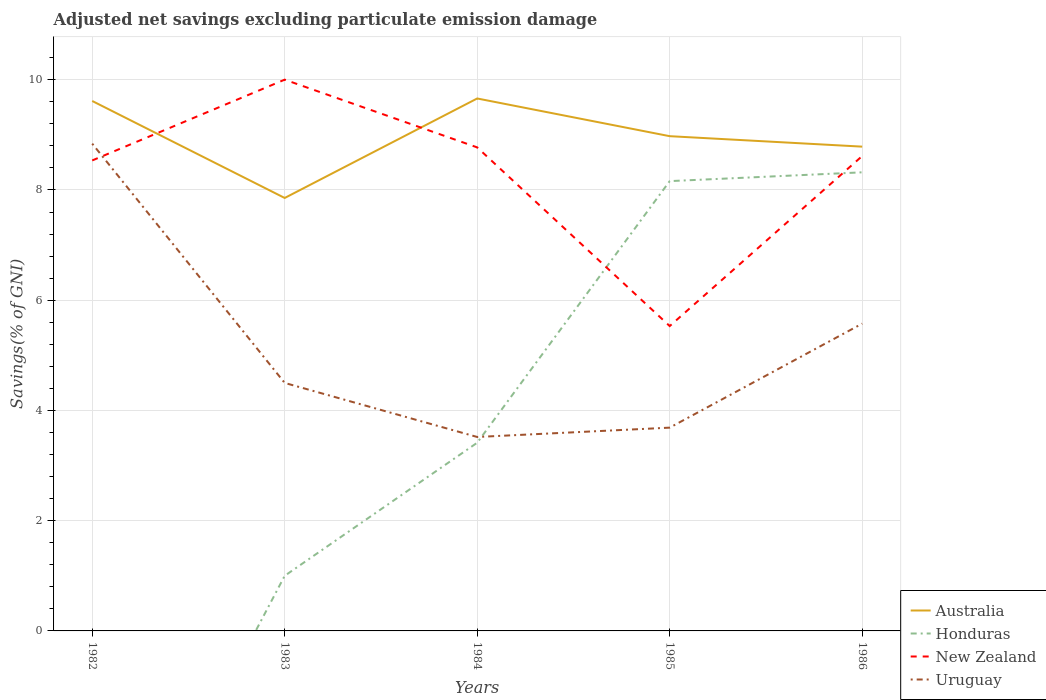How many different coloured lines are there?
Your response must be concise. 4. Does the line corresponding to Australia intersect with the line corresponding to Honduras?
Keep it short and to the point. No. Across all years, what is the maximum adjusted net savings in New Zealand?
Offer a very short reply. 5.53. What is the total adjusted net savings in Australia in the graph?
Your answer should be compact. 0.83. What is the difference between the highest and the second highest adjusted net savings in Uruguay?
Your response must be concise. 5.32. Is the adjusted net savings in Uruguay strictly greater than the adjusted net savings in Australia over the years?
Your answer should be compact. Yes. How many lines are there?
Your answer should be compact. 4. Are the values on the major ticks of Y-axis written in scientific E-notation?
Provide a short and direct response. No. Does the graph contain any zero values?
Ensure brevity in your answer.  Yes. Where does the legend appear in the graph?
Ensure brevity in your answer.  Bottom right. How many legend labels are there?
Ensure brevity in your answer.  4. What is the title of the graph?
Your response must be concise. Adjusted net savings excluding particulate emission damage. Does "Dominican Republic" appear as one of the legend labels in the graph?
Offer a terse response. No. What is the label or title of the Y-axis?
Your answer should be very brief. Savings(% of GNI). What is the Savings(% of GNI) in Australia in 1982?
Make the answer very short. 9.61. What is the Savings(% of GNI) of New Zealand in 1982?
Make the answer very short. 8.54. What is the Savings(% of GNI) in Uruguay in 1982?
Give a very brief answer. 8.84. What is the Savings(% of GNI) of Australia in 1983?
Offer a terse response. 7.85. What is the Savings(% of GNI) in Honduras in 1983?
Give a very brief answer. 1. What is the Savings(% of GNI) in New Zealand in 1983?
Offer a very short reply. 10. What is the Savings(% of GNI) in Uruguay in 1983?
Keep it short and to the point. 4.5. What is the Savings(% of GNI) of Australia in 1984?
Offer a terse response. 9.66. What is the Savings(% of GNI) in Honduras in 1984?
Offer a terse response. 3.41. What is the Savings(% of GNI) in New Zealand in 1984?
Ensure brevity in your answer.  8.77. What is the Savings(% of GNI) of Uruguay in 1984?
Ensure brevity in your answer.  3.52. What is the Savings(% of GNI) of Australia in 1985?
Your answer should be compact. 8.98. What is the Savings(% of GNI) in Honduras in 1985?
Offer a very short reply. 8.16. What is the Savings(% of GNI) in New Zealand in 1985?
Keep it short and to the point. 5.53. What is the Savings(% of GNI) of Uruguay in 1985?
Your answer should be compact. 3.69. What is the Savings(% of GNI) of Australia in 1986?
Provide a succinct answer. 8.79. What is the Savings(% of GNI) of Honduras in 1986?
Provide a succinct answer. 8.32. What is the Savings(% of GNI) of New Zealand in 1986?
Give a very brief answer. 8.62. What is the Savings(% of GNI) in Uruguay in 1986?
Offer a very short reply. 5.58. Across all years, what is the maximum Savings(% of GNI) of Australia?
Give a very brief answer. 9.66. Across all years, what is the maximum Savings(% of GNI) of Honduras?
Keep it short and to the point. 8.32. Across all years, what is the maximum Savings(% of GNI) in New Zealand?
Make the answer very short. 10. Across all years, what is the maximum Savings(% of GNI) of Uruguay?
Keep it short and to the point. 8.84. Across all years, what is the minimum Savings(% of GNI) of Australia?
Your answer should be very brief. 7.85. Across all years, what is the minimum Savings(% of GNI) in Honduras?
Give a very brief answer. 0. Across all years, what is the minimum Savings(% of GNI) in New Zealand?
Offer a very short reply. 5.53. Across all years, what is the minimum Savings(% of GNI) in Uruguay?
Ensure brevity in your answer.  3.52. What is the total Savings(% of GNI) of Australia in the graph?
Offer a terse response. 44.89. What is the total Savings(% of GNI) in Honduras in the graph?
Make the answer very short. 20.9. What is the total Savings(% of GNI) in New Zealand in the graph?
Provide a short and direct response. 41.46. What is the total Savings(% of GNI) of Uruguay in the graph?
Your response must be concise. 26.12. What is the difference between the Savings(% of GNI) of Australia in 1982 and that in 1983?
Offer a terse response. 1.76. What is the difference between the Savings(% of GNI) in New Zealand in 1982 and that in 1983?
Your answer should be very brief. -1.47. What is the difference between the Savings(% of GNI) of Uruguay in 1982 and that in 1983?
Provide a short and direct response. 4.34. What is the difference between the Savings(% of GNI) of Australia in 1982 and that in 1984?
Your answer should be compact. -0.05. What is the difference between the Savings(% of GNI) of New Zealand in 1982 and that in 1984?
Offer a very short reply. -0.24. What is the difference between the Savings(% of GNI) of Uruguay in 1982 and that in 1984?
Make the answer very short. 5.32. What is the difference between the Savings(% of GNI) of Australia in 1982 and that in 1985?
Keep it short and to the point. 0.64. What is the difference between the Savings(% of GNI) of New Zealand in 1982 and that in 1985?
Keep it short and to the point. 3. What is the difference between the Savings(% of GNI) of Uruguay in 1982 and that in 1985?
Provide a succinct answer. 5.15. What is the difference between the Savings(% of GNI) of Australia in 1982 and that in 1986?
Your answer should be compact. 0.83. What is the difference between the Savings(% of GNI) in New Zealand in 1982 and that in 1986?
Provide a succinct answer. -0.08. What is the difference between the Savings(% of GNI) in Uruguay in 1982 and that in 1986?
Give a very brief answer. 3.27. What is the difference between the Savings(% of GNI) in Australia in 1983 and that in 1984?
Give a very brief answer. -1.81. What is the difference between the Savings(% of GNI) in Honduras in 1983 and that in 1984?
Provide a succinct answer. -2.41. What is the difference between the Savings(% of GNI) in New Zealand in 1983 and that in 1984?
Ensure brevity in your answer.  1.23. What is the difference between the Savings(% of GNI) in Uruguay in 1983 and that in 1984?
Offer a very short reply. 0.98. What is the difference between the Savings(% of GNI) of Australia in 1983 and that in 1985?
Your answer should be very brief. -1.12. What is the difference between the Savings(% of GNI) of Honduras in 1983 and that in 1985?
Offer a terse response. -7.16. What is the difference between the Savings(% of GNI) of New Zealand in 1983 and that in 1985?
Offer a very short reply. 4.47. What is the difference between the Savings(% of GNI) of Uruguay in 1983 and that in 1985?
Your answer should be compact. 0.81. What is the difference between the Savings(% of GNI) in Australia in 1983 and that in 1986?
Make the answer very short. -0.93. What is the difference between the Savings(% of GNI) of Honduras in 1983 and that in 1986?
Provide a succinct answer. -7.32. What is the difference between the Savings(% of GNI) in New Zealand in 1983 and that in 1986?
Give a very brief answer. 1.39. What is the difference between the Savings(% of GNI) in Uruguay in 1983 and that in 1986?
Your answer should be compact. -1.08. What is the difference between the Savings(% of GNI) in Australia in 1984 and that in 1985?
Offer a terse response. 0.68. What is the difference between the Savings(% of GNI) of Honduras in 1984 and that in 1985?
Provide a short and direct response. -4.75. What is the difference between the Savings(% of GNI) in New Zealand in 1984 and that in 1985?
Offer a very short reply. 3.24. What is the difference between the Savings(% of GNI) in Uruguay in 1984 and that in 1985?
Your response must be concise. -0.17. What is the difference between the Savings(% of GNI) of Australia in 1984 and that in 1986?
Your answer should be very brief. 0.87. What is the difference between the Savings(% of GNI) in Honduras in 1984 and that in 1986?
Ensure brevity in your answer.  -4.91. What is the difference between the Savings(% of GNI) of New Zealand in 1984 and that in 1986?
Make the answer very short. 0.16. What is the difference between the Savings(% of GNI) in Uruguay in 1984 and that in 1986?
Provide a short and direct response. -2.06. What is the difference between the Savings(% of GNI) of Australia in 1985 and that in 1986?
Your response must be concise. 0.19. What is the difference between the Savings(% of GNI) of Honduras in 1985 and that in 1986?
Provide a succinct answer. -0.16. What is the difference between the Savings(% of GNI) in New Zealand in 1985 and that in 1986?
Your answer should be compact. -3.08. What is the difference between the Savings(% of GNI) of Uruguay in 1985 and that in 1986?
Provide a succinct answer. -1.89. What is the difference between the Savings(% of GNI) of Australia in 1982 and the Savings(% of GNI) of Honduras in 1983?
Provide a succinct answer. 8.61. What is the difference between the Savings(% of GNI) in Australia in 1982 and the Savings(% of GNI) in New Zealand in 1983?
Ensure brevity in your answer.  -0.39. What is the difference between the Savings(% of GNI) of Australia in 1982 and the Savings(% of GNI) of Uruguay in 1983?
Offer a terse response. 5.12. What is the difference between the Savings(% of GNI) of New Zealand in 1982 and the Savings(% of GNI) of Uruguay in 1983?
Give a very brief answer. 4.04. What is the difference between the Savings(% of GNI) in Australia in 1982 and the Savings(% of GNI) in Honduras in 1984?
Your answer should be compact. 6.2. What is the difference between the Savings(% of GNI) of Australia in 1982 and the Savings(% of GNI) of New Zealand in 1984?
Keep it short and to the point. 0.84. What is the difference between the Savings(% of GNI) of Australia in 1982 and the Savings(% of GNI) of Uruguay in 1984?
Keep it short and to the point. 6.1. What is the difference between the Savings(% of GNI) in New Zealand in 1982 and the Savings(% of GNI) in Uruguay in 1984?
Provide a short and direct response. 5.02. What is the difference between the Savings(% of GNI) in Australia in 1982 and the Savings(% of GNI) in Honduras in 1985?
Give a very brief answer. 1.45. What is the difference between the Savings(% of GNI) of Australia in 1982 and the Savings(% of GNI) of New Zealand in 1985?
Offer a terse response. 4.08. What is the difference between the Savings(% of GNI) of Australia in 1982 and the Savings(% of GNI) of Uruguay in 1985?
Offer a terse response. 5.93. What is the difference between the Savings(% of GNI) in New Zealand in 1982 and the Savings(% of GNI) in Uruguay in 1985?
Your answer should be compact. 4.85. What is the difference between the Savings(% of GNI) in Australia in 1982 and the Savings(% of GNI) in Honduras in 1986?
Your answer should be very brief. 1.29. What is the difference between the Savings(% of GNI) in Australia in 1982 and the Savings(% of GNI) in Uruguay in 1986?
Your answer should be very brief. 4.04. What is the difference between the Savings(% of GNI) in New Zealand in 1982 and the Savings(% of GNI) in Uruguay in 1986?
Offer a very short reply. 2.96. What is the difference between the Savings(% of GNI) in Australia in 1983 and the Savings(% of GNI) in Honduras in 1984?
Ensure brevity in your answer.  4.44. What is the difference between the Savings(% of GNI) in Australia in 1983 and the Savings(% of GNI) in New Zealand in 1984?
Give a very brief answer. -0.92. What is the difference between the Savings(% of GNI) in Australia in 1983 and the Savings(% of GNI) in Uruguay in 1984?
Provide a succinct answer. 4.34. What is the difference between the Savings(% of GNI) in Honduras in 1983 and the Savings(% of GNI) in New Zealand in 1984?
Offer a very short reply. -7.77. What is the difference between the Savings(% of GNI) of Honduras in 1983 and the Savings(% of GNI) of Uruguay in 1984?
Keep it short and to the point. -2.52. What is the difference between the Savings(% of GNI) of New Zealand in 1983 and the Savings(% of GNI) of Uruguay in 1984?
Give a very brief answer. 6.48. What is the difference between the Savings(% of GNI) of Australia in 1983 and the Savings(% of GNI) of Honduras in 1985?
Provide a short and direct response. -0.31. What is the difference between the Savings(% of GNI) of Australia in 1983 and the Savings(% of GNI) of New Zealand in 1985?
Your answer should be very brief. 2.32. What is the difference between the Savings(% of GNI) in Australia in 1983 and the Savings(% of GNI) in Uruguay in 1985?
Provide a succinct answer. 4.17. What is the difference between the Savings(% of GNI) in Honduras in 1983 and the Savings(% of GNI) in New Zealand in 1985?
Offer a very short reply. -4.53. What is the difference between the Savings(% of GNI) of Honduras in 1983 and the Savings(% of GNI) of Uruguay in 1985?
Give a very brief answer. -2.69. What is the difference between the Savings(% of GNI) of New Zealand in 1983 and the Savings(% of GNI) of Uruguay in 1985?
Your response must be concise. 6.31. What is the difference between the Savings(% of GNI) of Australia in 1983 and the Savings(% of GNI) of Honduras in 1986?
Give a very brief answer. -0.47. What is the difference between the Savings(% of GNI) in Australia in 1983 and the Savings(% of GNI) in New Zealand in 1986?
Your answer should be compact. -0.76. What is the difference between the Savings(% of GNI) in Australia in 1983 and the Savings(% of GNI) in Uruguay in 1986?
Make the answer very short. 2.28. What is the difference between the Savings(% of GNI) of Honduras in 1983 and the Savings(% of GNI) of New Zealand in 1986?
Make the answer very short. -7.62. What is the difference between the Savings(% of GNI) of Honduras in 1983 and the Savings(% of GNI) of Uruguay in 1986?
Keep it short and to the point. -4.58. What is the difference between the Savings(% of GNI) in New Zealand in 1983 and the Savings(% of GNI) in Uruguay in 1986?
Your answer should be compact. 4.43. What is the difference between the Savings(% of GNI) in Australia in 1984 and the Savings(% of GNI) in Honduras in 1985?
Your response must be concise. 1.5. What is the difference between the Savings(% of GNI) of Australia in 1984 and the Savings(% of GNI) of New Zealand in 1985?
Give a very brief answer. 4.13. What is the difference between the Savings(% of GNI) of Australia in 1984 and the Savings(% of GNI) of Uruguay in 1985?
Your response must be concise. 5.97. What is the difference between the Savings(% of GNI) in Honduras in 1984 and the Savings(% of GNI) in New Zealand in 1985?
Keep it short and to the point. -2.12. What is the difference between the Savings(% of GNI) of Honduras in 1984 and the Savings(% of GNI) of Uruguay in 1985?
Your answer should be compact. -0.27. What is the difference between the Savings(% of GNI) of New Zealand in 1984 and the Savings(% of GNI) of Uruguay in 1985?
Your response must be concise. 5.08. What is the difference between the Savings(% of GNI) of Australia in 1984 and the Savings(% of GNI) of Honduras in 1986?
Your answer should be compact. 1.34. What is the difference between the Savings(% of GNI) in Australia in 1984 and the Savings(% of GNI) in New Zealand in 1986?
Ensure brevity in your answer.  1.04. What is the difference between the Savings(% of GNI) in Australia in 1984 and the Savings(% of GNI) in Uruguay in 1986?
Your answer should be compact. 4.08. What is the difference between the Savings(% of GNI) in Honduras in 1984 and the Savings(% of GNI) in New Zealand in 1986?
Offer a terse response. -5.2. What is the difference between the Savings(% of GNI) of Honduras in 1984 and the Savings(% of GNI) of Uruguay in 1986?
Offer a terse response. -2.16. What is the difference between the Savings(% of GNI) of New Zealand in 1984 and the Savings(% of GNI) of Uruguay in 1986?
Your answer should be compact. 3.2. What is the difference between the Savings(% of GNI) of Australia in 1985 and the Savings(% of GNI) of Honduras in 1986?
Keep it short and to the point. 0.66. What is the difference between the Savings(% of GNI) in Australia in 1985 and the Savings(% of GNI) in New Zealand in 1986?
Make the answer very short. 0.36. What is the difference between the Savings(% of GNI) of Australia in 1985 and the Savings(% of GNI) of Uruguay in 1986?
Make the answer very short. 3.4. What is the difference between the Savings(% of GNI) in Honduras in 1985 and the Savings(% of GNI) in New Zealand in 1986?
Ensure brevity in your answer.  -0.46. What is the difference between the Savings(% of GNI) of Honduras in 1985 and the Savings(% of GNI) of Uruguay in 1986?
Ensure brevity in your answer.  2.59. What is the difference between the Savings(% of GNI) in New Zealand in 1985 and the Savings(% of GNI) in Uruguay in 1986?
Provide a succinct answer. -0.04. What is the average Savings(% of GNI) of Australia per year?
Provide a short and direct response. 8.98. What is the average Savings(% of GNI) of Honduras per year?
Make the answer very short. 4.18. What is the average Savings(% of GNI) in New Zealand per year?
Keep it short and to the point. 8.29. What is the average Savings(% of GNI) of Uruguay per year?
Make the answer very short. 5.22. In the year 1982, what is the difference between the Savings(% of GNI) of Australia and Savings(% of GNI) of New Zealand?
Keep it short and to the point. 1.08. In the year 1982, what is the difference between the Savings(% of GNI) of Australia and Savings(% of GNI) of Uruguay?
Provide a short and direct response. 0.77. In the year 1982, what is the difference between the Savings(% of GNI) of New Zealand and Savings(% of GNI) of Uruguay?
Your answer should be compact. -0.3. In the year 1983, what is the difference between the Savings(% of GNI) in Australia and Savings(% of GNI) in Honduras?
Provide a short and direct response. 6.85. In the year 1983, what is the difference between the Savings(% of GNI) of Australia and Savings(% of GNI) of New Zealand?
Ensure brevity in your answer.  -2.15. In the year 1983, what is the difference between the Savings(% of GNI) in Australia and Savings(% of GNI) in Uruguay?
Provide a short and direct response. 3.36. In the year 1983, what is the difference between the Savings(% of GNI) of Honduras and Savings(% of GNI) of New Zealand?
Give a very brief answer. -9. In the year 1983, what is the difference between the Savings(% of GNI) in Honduras and Savings(% of GNI) in Uruguay?
Make the answer very short. -3.5. In the year 1983, what is the difference between the Savings(% of GNI) of New Zealand and Savings(% of GNI) of Uruguay?
Provide a succinct answer. 5.5. In the year 1984, what is the difference between the Savings(% of GNI) of Australia and Savings(% of GNI) of Honduras?
Offer a very short reply. 6.25. In the year 1984, what is the difference between the Savings(% of GNI) in Australia and Savings(% of GNI) in New Zealand?
Your answer should be compact. 0.89. In the year 1984, what is the difference between the Savings(% of GNI) of Australia and Savings(% of GNI) of Uruguay?
Provide a short and direct response. 6.14. In the year 1984, what is the difference between the Savings(% of GNI) of Honduras and Savings(% of GNI) of New Zealand?
Your answer should be compact. -5.36. In the year 1984, what is the difference between the Savings(% of GNI) of Honduras and Savings(% of GNI) of Uruguay?
Your answer should be very brief. -0.1. In the year 1984, what is the difference between the Savings(% of GNI) of New Zealand and Savings(% of GNI) of Uruguay?
Keep it short and to the point. 5.25. In the year 1985, what is the difference between the Savings(% of GNI) of Australia and Savings(% of GNI) of Honduras?
Ensure brevity in your answer.  0.82. In the year 1985, what is the difference between the Savings(% of GNI) in Australia and Savings(% of GNI) in New Zealand?
Make the answer very short. 3.44. In the year 1985, what is the difference between the Savings(% of GNI) of Australia and Savings(% of GNI) of Uruguay?
Keep it short and to the point. 5.29. In the year 1985, what is the difference between the Savings(% of GNI) of Honduras and Savings(% of GNI) of New Zealand?
Offer a very short reply. 2.63. In the year 1985, what is the difference between the Savings(% of GNI) of Honduras and Savings(% of GNI) of Uruguay?
Offer a terse response. 4.47. In the year 1985, what is the difference between the Savings(% of GNI) of New Zealand and Savings(% of GNI) of Uruguay?
Provide a short and direct response. 1.84. In the year 1986, what is the difference between the Savings(% of GNI) of Australia and Savings(% of GNI) of Honduras?
Make the answer very short. 0.47. In the year 1986, what is the difference between the Savings(% of GNI) of Australia and Savings(% of GNI) of New Zealand?
Make the answer very short. 0.17. In the year 1986, what is the difference between the Savings(% of GNI) of Australia and Savings(% of GNI) of Uruguay?
Your response must be concise. 3.21. In the year 1986, what is the difference between the Savings(% of GNI) of Honduras and Savings(% of GNI) of New Zealand?
Offer a terse response. -0.3. In the year 1986, what is the difference between the Savings(% of GNI) in Honduras and Savings(% of GNI) in Uruguay?
Give a very brief answer. 2.75. In the year 1986, what is the difference between the Savings(% of GNI) of New Zealand and Savings(% of GNI) of Uruguay?
Your answer should be very brief. 3.04. What is the ratio of the Savings(% of GNI) of Australia in 1982 to that in 1983?
Offer a very short reply. 1.22. What is the ratio of the Savings(% of GNI) in New Zealand in 1982 to that in 1983?
Your response must be concise. 0.85. What is the ratio of the Savings(% of GNI) of Uruguay in 1982 to that in 1983?
Provide a short and direct response. 1.96. What is the ratio of the Savings(% of GNI) of Uruguay in 1982 to that in 1984?
Provide a succinct answer. 2.51. What is the ratio of the Savings(% of GNI) in Australia in 1982 to that in 1985?
Your answer should be compact. 1.07. What is the ratio of the Savings(% of GNI) of New Zealand in 1982 to that in 1985?
Provide a short and direct response. 1.54. What is the ratio of the Savings(% of GNI) in Uruguay in 1982 to that in 1985?
Your answer should be very brief. 2.4. What is the ratio of the Savings(% of GNI) of Australia in 1982 to that in 1986?
Your answer should be very brief. 1.09. What is the ratio of the Savings(% of GNI) of Uruguay in 1982 to that in 1986?
Keep it short and to the point. 1.59. What is the ratio of the Savings(% of GNI) of Australia in 1983 to that in 1984?
Ensure brevity in your answer.  0.81. What is the ratio of the Savings(% of GNI) of Honduras in 1983 to that in 1984?
Keep it short and to the point. 0.29. What is the ratio of the Savings(% of GNI) in New Zealand in 1983 to that in 1984?
Make the answer very short. 1.14. What is the ratio of the Savings(% of GNI) of Uruguay in 1983 to that in 1984?
Offer a very short reply. 1.28. What is the ratio of the Savings(% of GNI) in Australia in 1983 to that in 1985?
Offer a terse response. 0.88. What is the ratio of the Savings(% of GNI) of Honduras in 1983 to that in 1985?
Offer a terse response. 0.12. What is the ratio of the Savings(% of GNI) in New Zealand in 1983 to that in 1985?
Offer a terse response. 1.81. What is the ratio of the Savings(% of GNI) of Uruguay in 1983 to that in 1985?
Provide a short and direct response. 1.22. What is the ratio of the Savings(% of GNI) in Australia in 1983 to that in 1986?
Keep it short and to the point. 0.89. What is the ratio of the Savings(% of GNI) in Honduras in 1983 to that in 1986?
Your answer should be very brief. 0.12. What is the ratio of the Savings(% of GNI) of New Zealand in 1983 to that in 1986?
Offer a very short reply. 1.16. What is the ratio of the Savings(% of GNI) in Uruguay in 1983 to that in 1986?
Give a very brief answer. 0.81. What is the ratio of the Savings(% of GNI) in Australia in 1984 to that in 1985?
Your response must be concise. 1.08. What is the ratio of the Savings(% of GNI) of Honduras in 1984 to that in 1985?
Offer a terse response. 0.42. What is the ratio of the Savings(% of GNI) in New Zealand in 1984 to that in 1985?
Ensure brevity in your answer.  1.59. What is the ratio of the Savings(% of GNI) of Uruguay in 1984 to that in 1985?
Your response must be concise. 0.95. What is the ratio of the Savings(% of GNI) of Australia in 1984 to that in 1986?
Provide a short and direct response. 1.1. What is the ratio of the Savings(% of GNI) in Honduras in 1984 to that in 1986?
Make the answer very short. 0.41. What is the ratio of the Savings(% of GNI) in New Zealand in 1984 to that in 1986?
Ensure brevity in your answer.  1.02. What is the ratio of the Savings(% of GNI) in Uruguay in 1984 to that in 1986?
Keep it short and to the point. 0.63. What is the ratio of the Savings(% of GNI) in Australia in 1985 to that in 1986?
Offer a very short reply. 1.02. What is the ratio of the Savings(% of GNI) of Honduras in 1985 to that in 1986?
Give a very brief answer. 0.98. What is the ratio of the Savings(% of GNI) of New Zealand in 1985 to that in 1986?
Ensure brevity in your answer.  0.64. What is the ratio of the Savings(% of GNI) of Uruguay in 1985 to that in 1986?
Provide a short and direct response. 0.66. What is the difference between the highest and the second highest Savings(% of GNI) in Australia?
Keep it short and to the point. 0.05. What is the difference between the highest and the second highest Savings(% of GNI) of Honduras?
Give a very brief answer. 0.16. What is the difference between the highest and the second highest Savings(% of GNI) of New Zealand?
Provide a succinct answer. 1.23. What is the difference between the highest and the second highest Savings(% of GNI) of Uruguay?
Ensure brevity in your answer.  3.27. What is the difference between the highest and the lowest Savings(% of GNI) of Australia?
Offer a very short reply. 1.81. What is the difference between the highest and the lowest Savings(% of GNI) in Honduras?
Your answer should be very brief. 8.32. What is the difference between the highest and the lowest Savings(% of GNI) in New Zealand?
Your answer should be very brief. 4.47. What is the difference between the highest and the lowest Savings(% of GNI) of Uruguay?
Give a very brief answer. 5.32. 